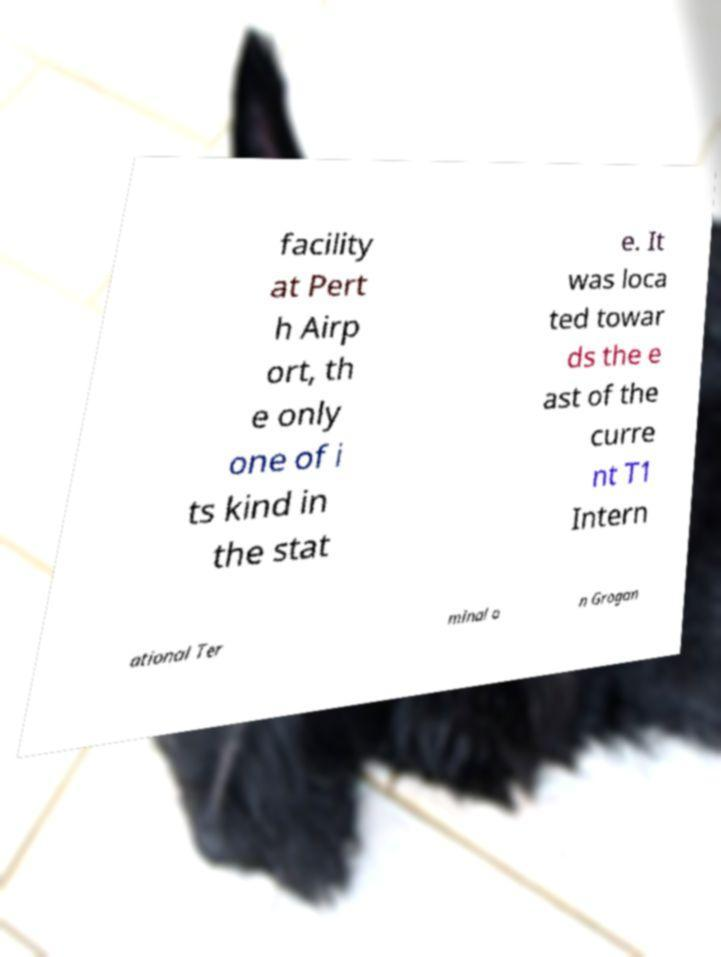Could you assist in decoding the text presented in this image and type it out clearly? facility at Pert h Airp ort, th e only one of i ts kind in the stat e. It was loca ted towar ds the e ast of the curre nt T1 Intern ational Ter minal o n Grogan 